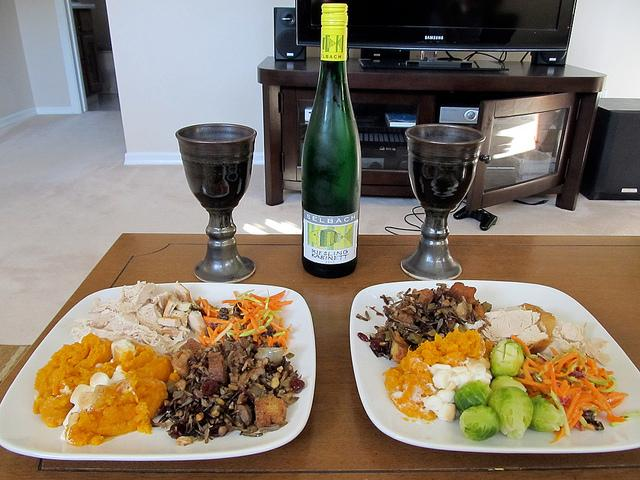Where in the house are they likely planning to dine? living room 